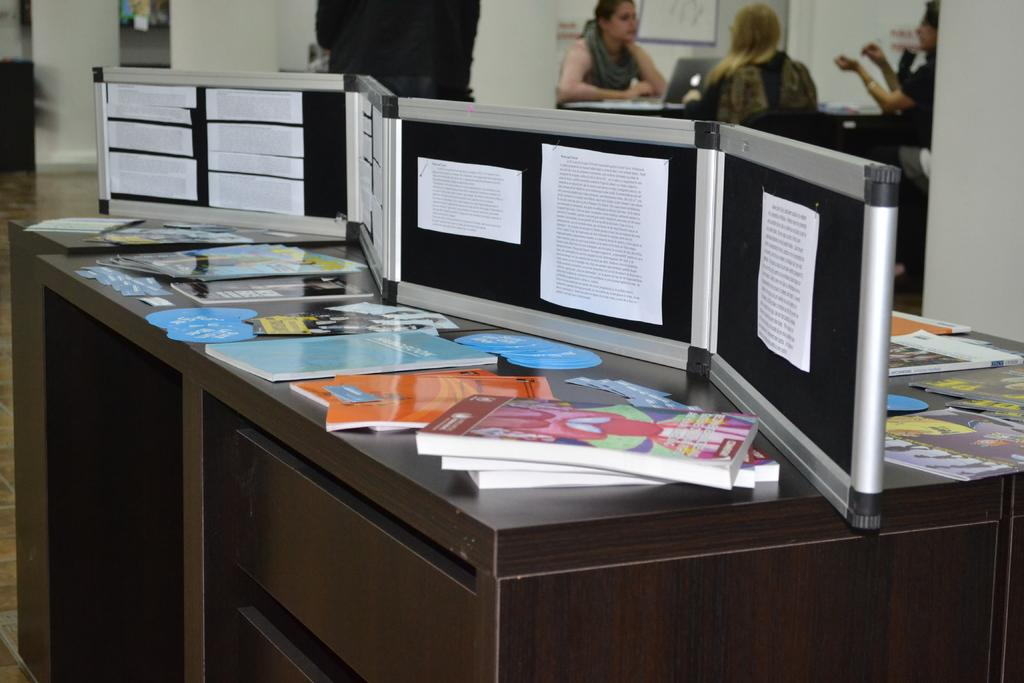How many people are in the image? There are three people in the image. What are the people doing in the image? The people are sitting on chairs. What can be seen on the table in the image? There is a laptop, a book, and a board on the table. What type of basketball game is being played on the table in the image? There is no basketball game present in the image; it features a table with a laptop, a book, and a board. What is the purpose of the fire in the image? There is no fire present in the image. 